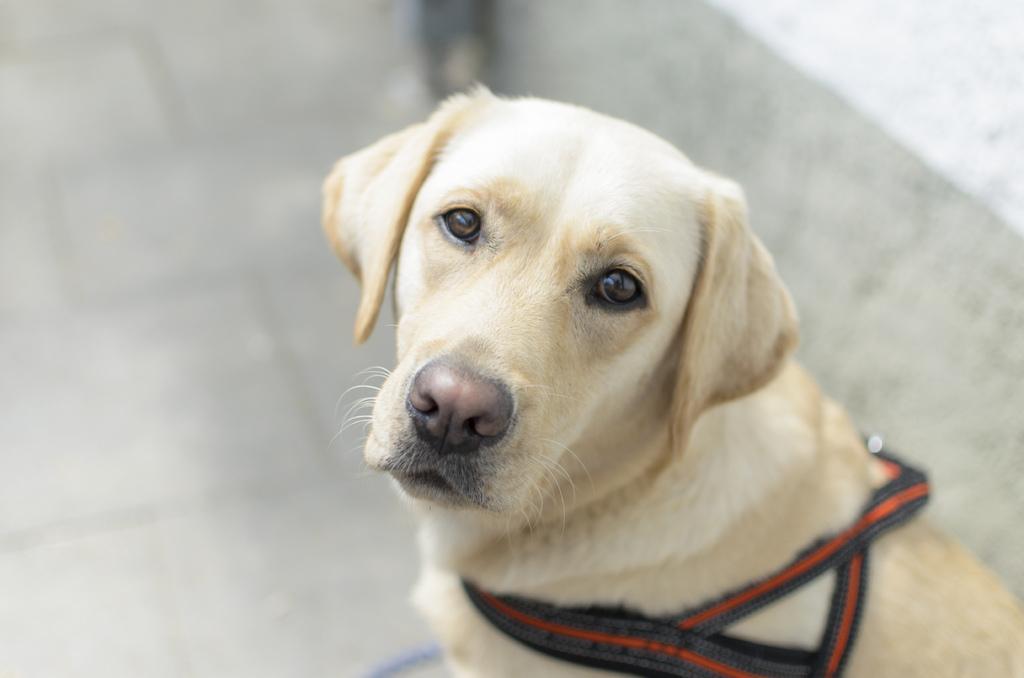Please provide a concise description of this image. In this picture I can see there is a dog and sitting here and it has cream color fur and it has a belt around its neck and the backdrop is blurred. 